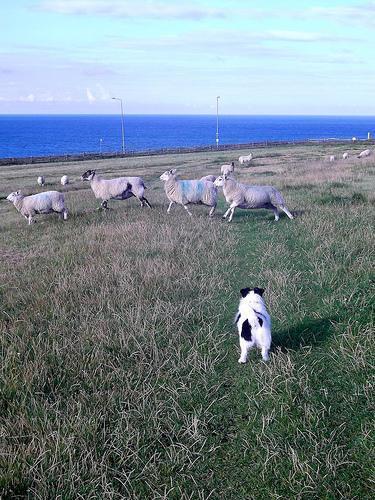How many dogs are in this page?
Give a very brief answer. 1. 